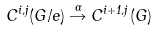Convert formula to latex. <formula><loc_0><loc_0><loc_500><loc_500>C ^ { i , j } ( G / e ) \overset { \alpha } { \rightarrow } C ^ { i + 1 , j } ( G )</formula> 